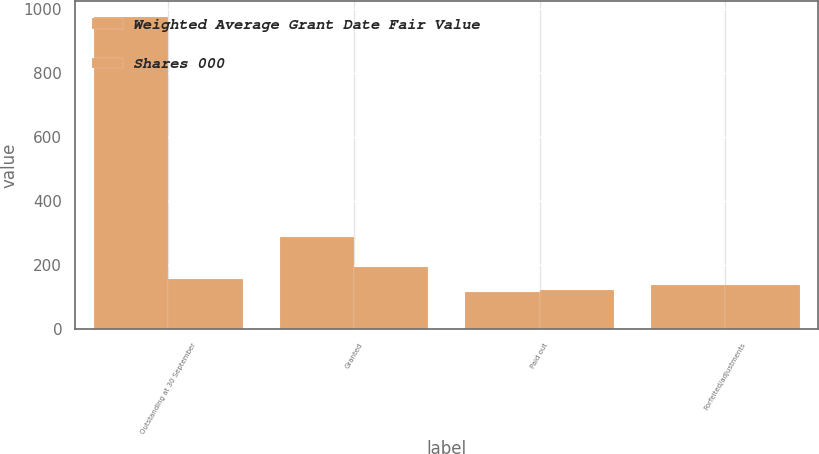Convert chart. <chart><loc_0><loc_0><loc_500><loc_500><stacked_bar_chart><ecel><fcel>Outstanding at 30 September<fcel>Granted<fcel>Paid out<fcel>Forfeited/adjustments<nl><fcel>Weighted Average Grant Date Fair Value<fcel>976<fcel>285<fcel>113<fcel>136<nl><fcel>Shares 000<fcel>156.31<fcel>193.29<fcel>119.59<fcel>136.11<nl></chart> 